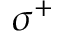<formula> <loc_0><loc_0><loc_500><loc_500>\sigma ^ { + }</formula> 